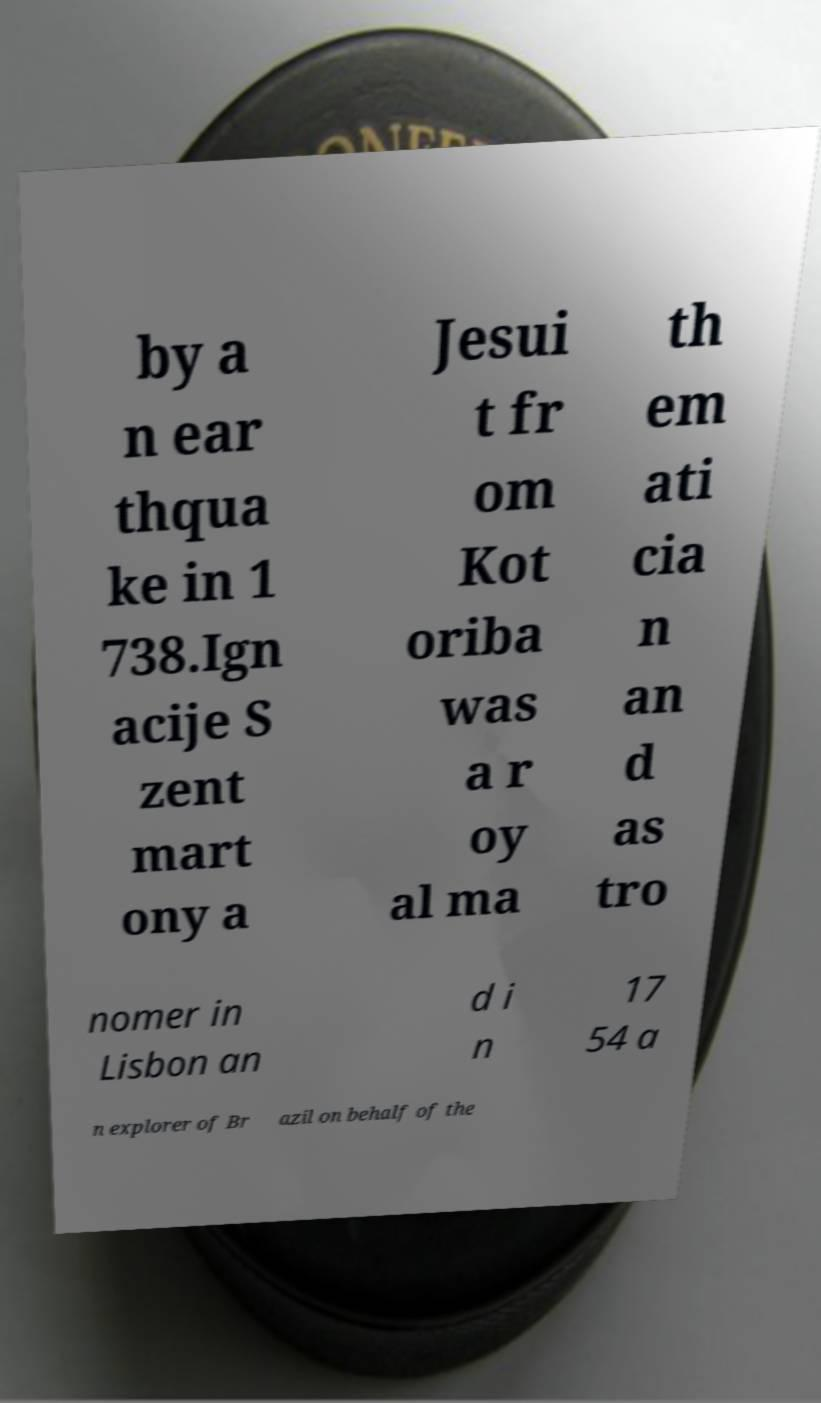Could you assist in decoding the text presented in this image and type it out clearly? by a n ear thqua ke in 1 738.Ign acije S zent mart ony a Jesui t fr om Kot oriba was a r oy al ma th em ati cia n an d as tro nomer in Lisbon an d i n 17 54 a n explorer of Br azil on behalf of the 